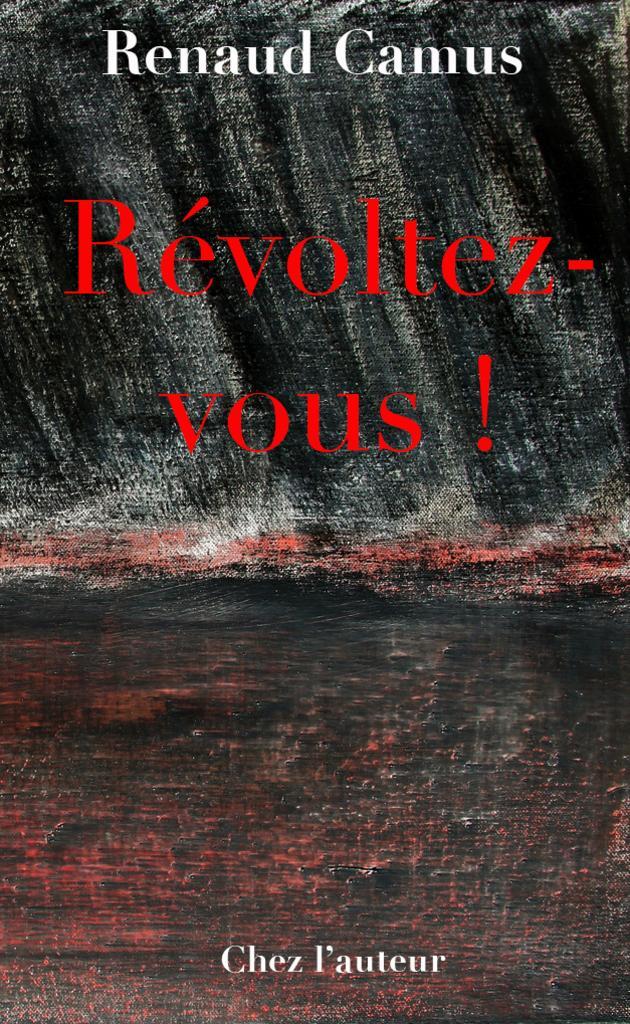Can you describe this image briefly? In this image there is a poster with some text on it. 